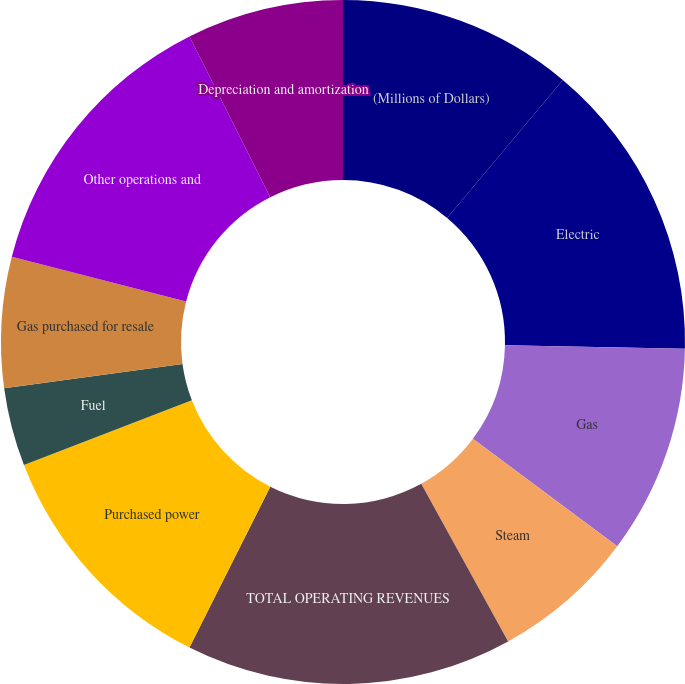<chart> <loc_0><loc_0><loc_500><loc_500><pie_chart><fcel>(Millions of Dollars)<fcel>Electric<fcel>Gas<fcel>Steam<fcel>TOTAL OPERATING REVENUES<fcel>Purchased power<fcel>Fuel<fcel>Gas purchased for resale<fcel>Other operations and<fcel>Depreciation and amortization<nl><fcel>11.11%<fcel>14.2%<fcel>9.88%<fcel>6.79%<fcel>15.43%<fcel>11.73%<fcel>3.7%<fcel>6.17%<fcel>13.58%<fcel>7.41%<nl></chart> 